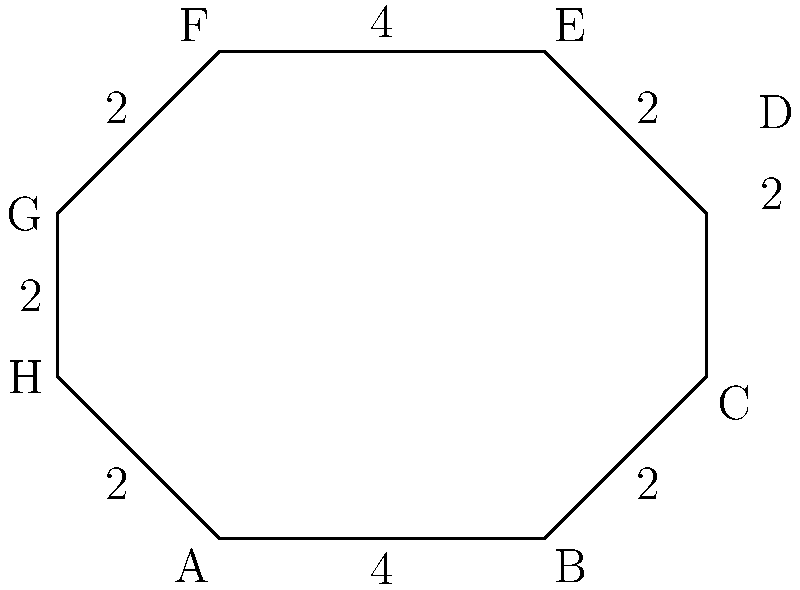As a devoted AS Monaco FC fan, you're analyzing the Stade Louis II from an aerial view. The stadium's shape resembles an octagon, as shown in the diagram. If the lengths of the sides are as indicated (in units of 100 meters), what is the perimeter of the stadium in kilometers? Let's approach this step-by-step:

1) First, we need to sum up all the side lengths of the octagon:
   $$4 + 2 + 2 + 2 + 4 + 2 + 2 + 2 = 20$$

2) This sum (20) is in units of 100 meters. To convert to kilometers:
   $$20 \times 100 \text{ meters} = 2000 \text{ meters}$$

3) Now, we convert meters to kilometers:
   $$2000 \text{ meters} = 2 \text{ kilometers}$$

Therefore, the perimeter of the Stade Louis II, based on this octagonal representation, is 2 kilometers.
Answer: 2 km 